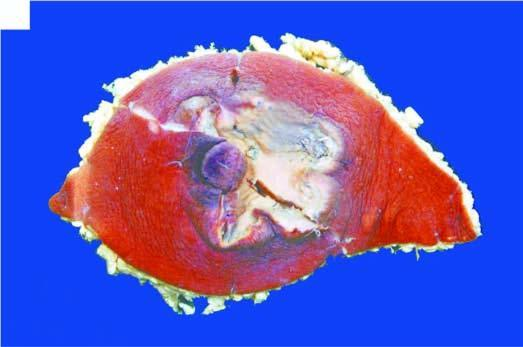s the region of nipple and areola crusted and ulcerated?
Answer the question using a single word or phrase. Yes 